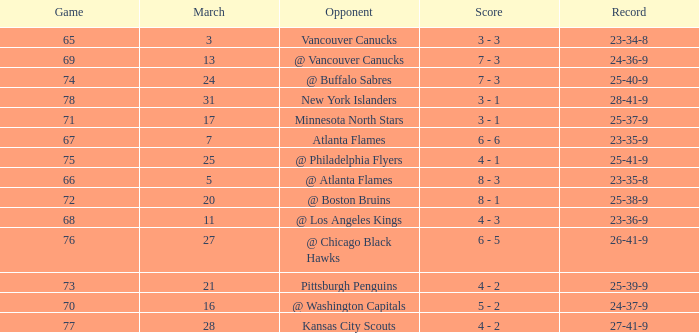What was the score when they had a 25-41-9 record? 4 - 1. 